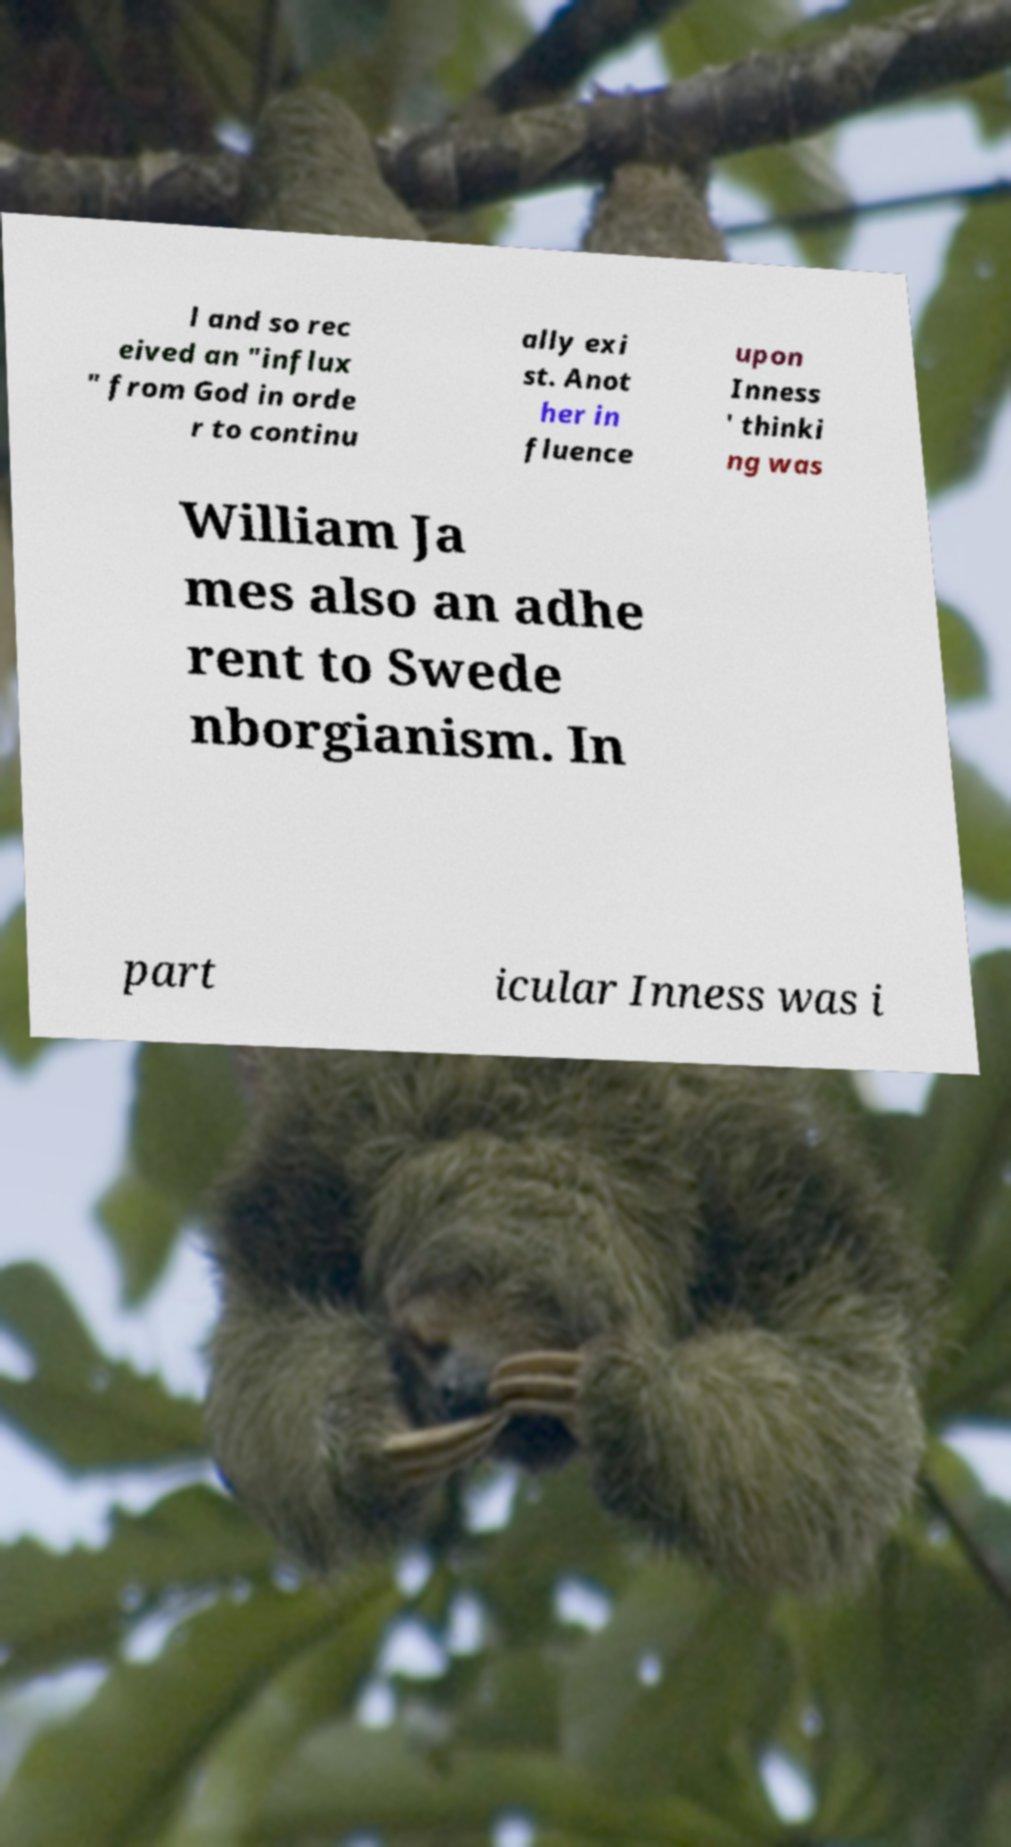I need the written content from this picture converted into text. Can you do that? l and so rec eived an "influx " from God in orde r to continu ally exi st. Anot her in fluence upon Inness ' thinki ng was William Ja mes also an adhe rent to Swede nborgianism. In part icular Inness was i 